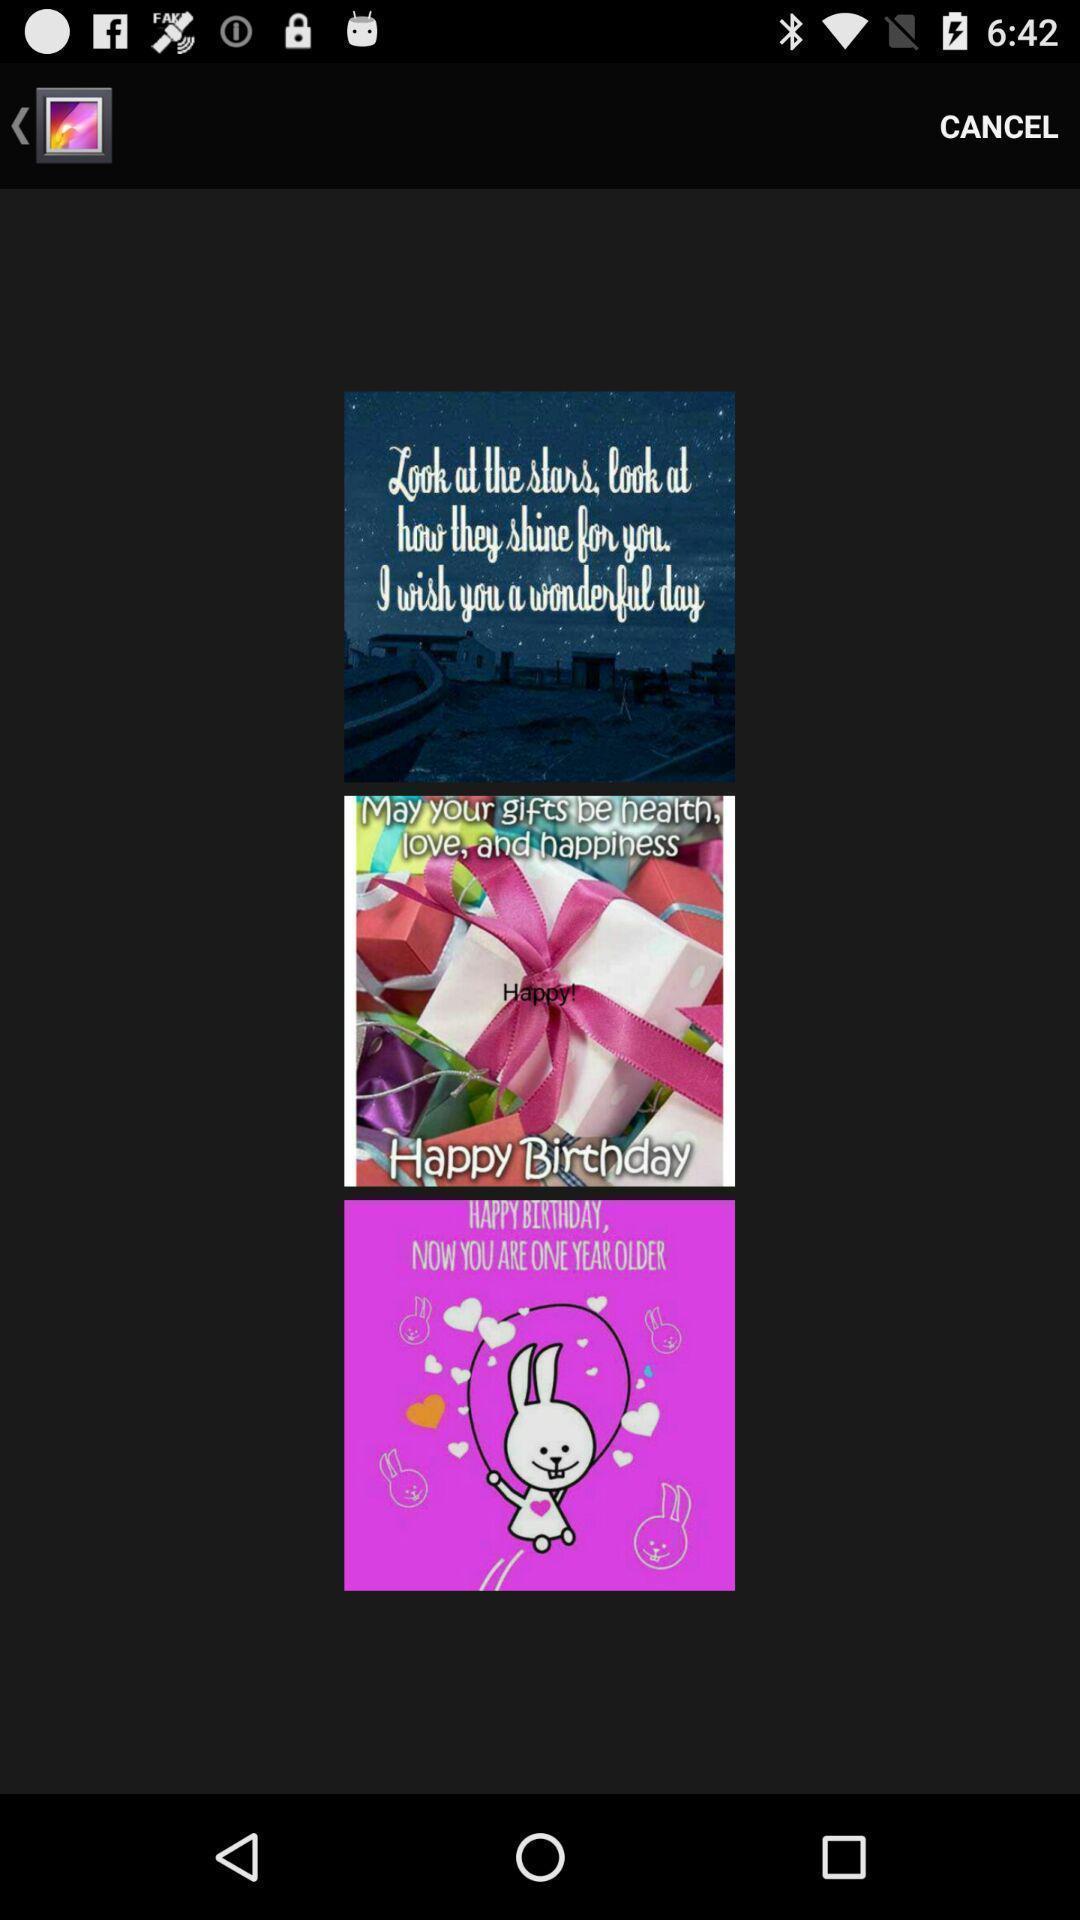Provide a textual representation of this image. Screen showing images. 